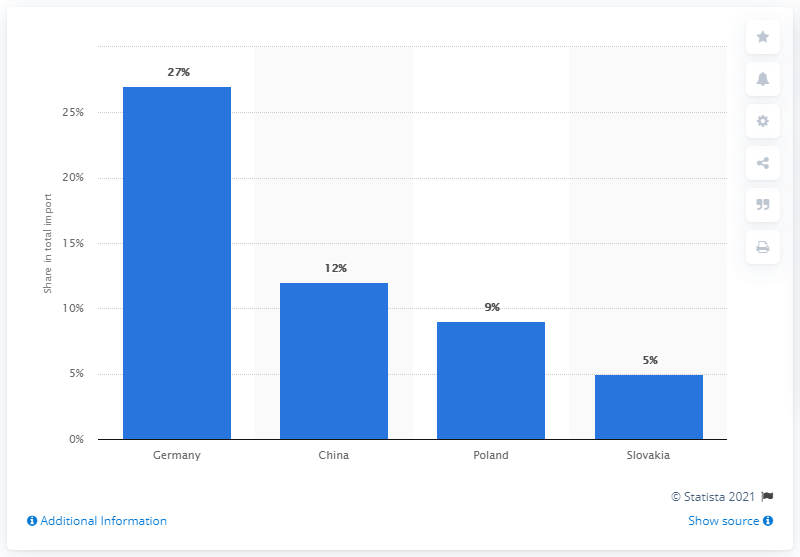Point out several critical features in this image. In 2019, Germany was the most significant import partner for the Czech Republic. 